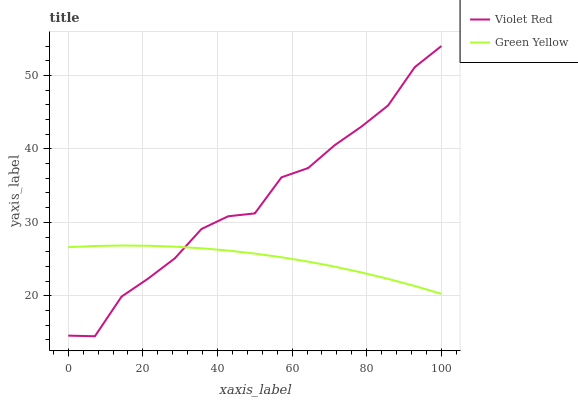Does Green Yellow have the minimum area under the curve?
Answer yes or no. Yes. Does Violet Red have the maximum area under the curve?
Answer yes or no. Yes. Does Green Yellow have the maximum area under the curve?
Answer yes or no. No. Is Green Yellow the smoothest?
Answer yes or no. Yes. Is Violet Red the roughest?
Answer yes or no. Yes. Is Green Yellow the roughest?
Answer yes or no. No. Does Violet Red have the lowest value?
Answer yes or no. Yes. Does Green Yellow have the lowest value?
Answer yes or no. No. Does Violet Red have the highest value?
Answer yes or no. Yes. Does Green Yellow have the highest value?
Answer yes or no. No. Does Violet Red intersect Green Yellow?
Answer yes or no. Yes. Is Violet Red less than Green Yellow?
Answer yes or no. No. Is Violet Red greater than Green Yellow?
Answer yes or no. No. 